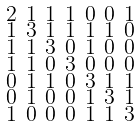Convert formula to latex. <formula><loc_0><loc_0><loc_500><loc_500>\begin{smallmatrix} 2 & 1 & 1 & 1 & 0 & 0 & 1 \\ 1 & 3 & 1 & 1 & 1 & 1 & 0 \\ 1 & 1 & 3 & 0 & 1 & 0 & 0 \\ 1 & 1 & 0 & 3 & 0 & 0 & 0 \\ 0 & 1 & 1 & 0 & 3 & 1 & 1 \\ 0 & 1 & 0 & 0 & 1 & 3 & 1 \\ 1 & 0 & 0 & 0 & 1 & 1 & 3 \end{smallmatrix}</formula> 